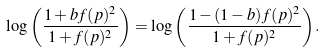<formula> <loc_0><loc_0><loc_500><loc_500>\log { \left ( \frac { 1 + b f ( p ) ^ { 2 } } { 1 + f ( p ) ^ { 2 } } \right ) } = \log { \left ( \frac { 1 - ( 1 - b ) f ( p ) ^ { 2 } } { 1 + f ( p ) ^ { 2 } } \right ) } .</formula> 